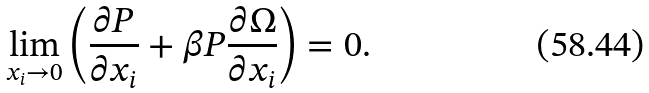<formula> <loc_0><loc_0><loc_500><loc_500>\lim _ { x _ { i } \rightarrow 0 } \left ( \frac { \partial P } { \partial x _ { i } } + \beta P \frac { \partial \Omega } { \partial x _ { i } } \right ) = 0 .</formula> 